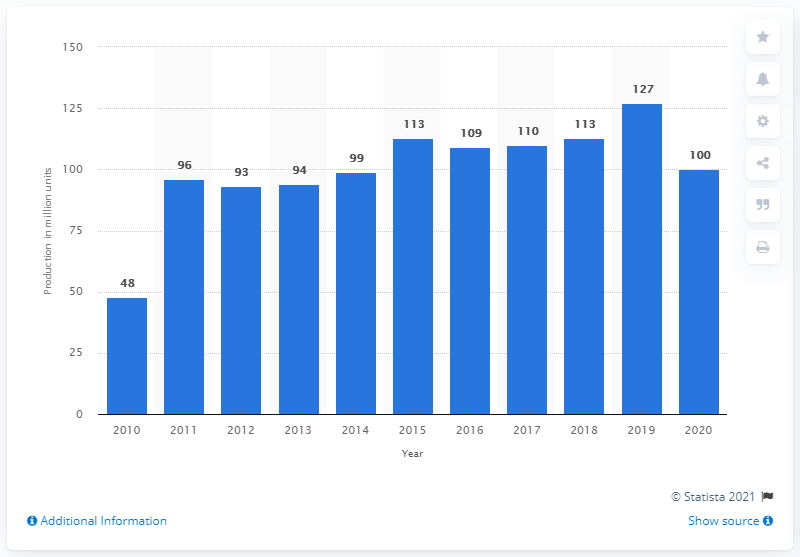Indicate a few pertinent items in this graphic. The adidas Group produced 100 accessories and gear in 2020. 